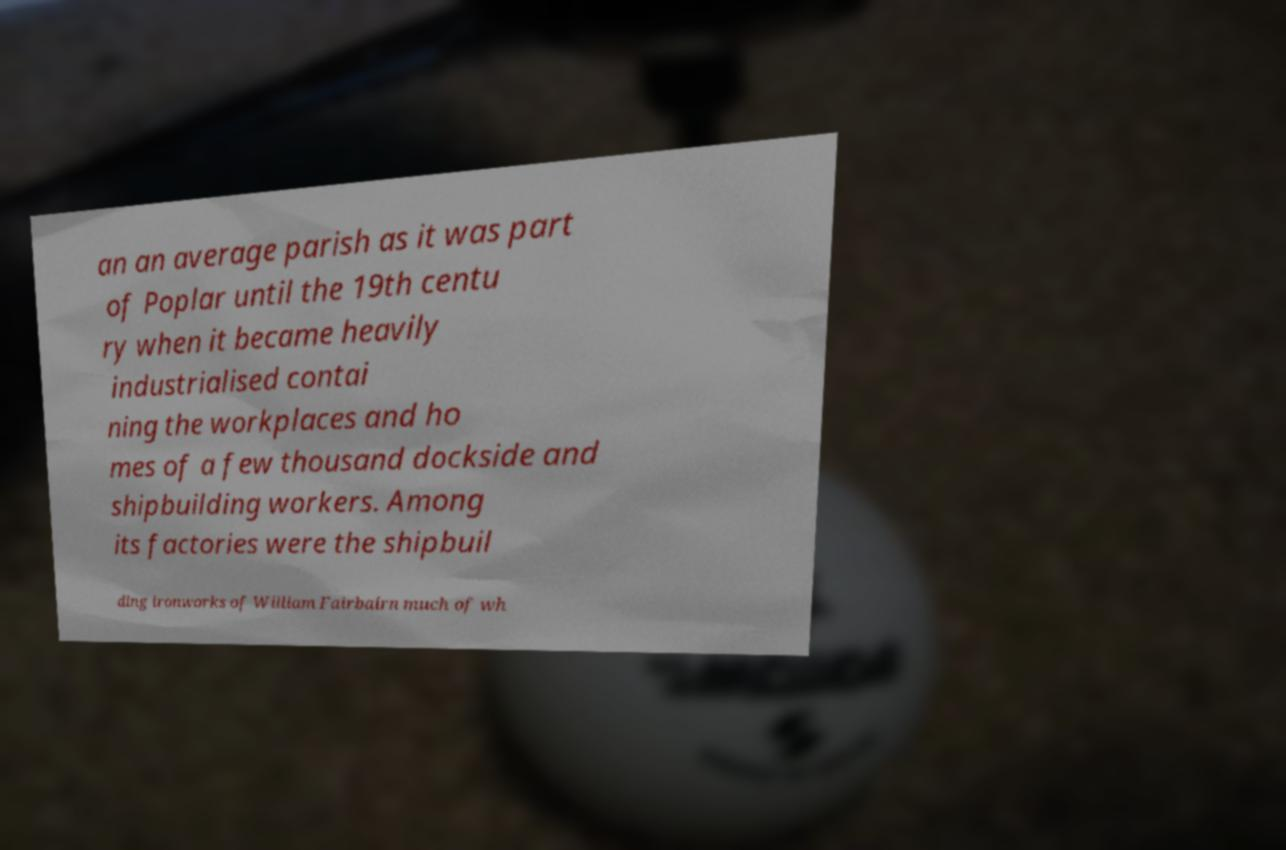I need the written content from this picture converted into text. Can you do that? an an average parish as it was part of Poplar until the 19th centu ry when it became heavily industrialised contai ning the workplaces and ho mes of a few thousand dockside and shipbuilding workers. Among its factories were the shipbuil ding ironworks of William Fairbairn much of wh 